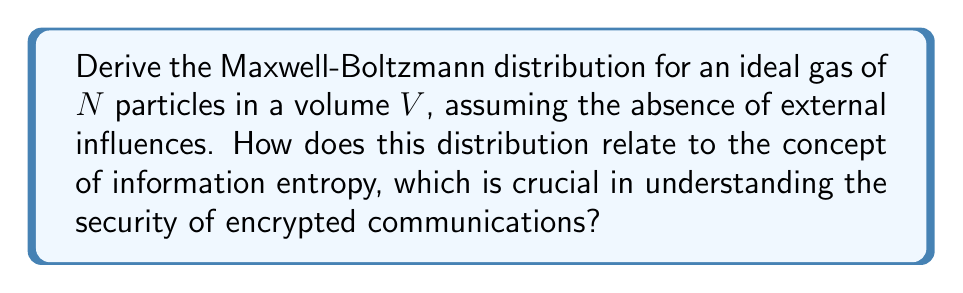Can you answer this question? Let's derive the Maxwell-Boltzmann distribution step-by-step:

1) We start with the canonical ensemble partition function:

   $$Z = \sum_i e^{-\beta E_i}$$

   where $\beta = \frac{1}{k_B T}$, $k_B$ is Boltzmann's constant, and T is temperature.

2) For an ideal gas, the energy is purely kinetic:

   $$E = \frac{1}{2}m(v_x^2 + v_y^2 + v_z^2)$$

3) The partition function becomes:

   $$Z = \left(\frac{V}{h^3}\right)^N \int e^{-\beta \frac{1}{2}m(v_x^2 + v_y^2 + v_z^2)} dv_x dv_y dv_z$$

4) This integral can be separated into three identical integrals:

   $$Z = \left(\frac{V}{h^3}\right)^N \left(\int e^{-\beta \frac{1}{2}mv_x^2} dv_x\right)^3$$

5) Each integral is a Gaussian integral with solution:

   $$\int e^{-\beta \frac{1}{2}mv_x^2} dv_x = \sqrt{\frac{2\pi}{\beta m}}$$

6) Substituting back:

   $$Z = \left(\frac{V}{h^3}\right)^N \left(\frac{2\pi m}{\beta}\right)^{3N/2}$$

7) The probability of finding a particle with velocity between $\vec{v}$ and $\vec{v} + d\vec{v}$ is:

   $$P(\vec{v})d\vec{v} = \frac{1}{Z} e^{-\beta \frac{1}{2}m(v_x^2 + v_y^2 + v_z^2)} d\vec{v}$$

8) Substituting Z and simplifying:

   $$P(\vec{v}) = \left(\frac{m}{2\pi k_B T}\right)^{3/2} e^{-\frac{m(v_x^2 + v_y^2 + v_z^2)}{2k_B T}}$$

This is the Maxwell-Boltzmann distribution.

Regarding information entropy, the Maxwell-Boltzmann distribution maximizes the Gibbs entropy:

$$S = -k_B \sum_i p_i \ln p_i$$

This is analogous to Shannon entropy in information theory:

$$H = -\sum_i p_i \log_2 p_i$$

Both measure the uncertainty or randomness in a system. In cryptography, high entropy is desired for secure encryption keys, as it increases the difficulty of guessing or breaking the encryption.
Answer: $$P(\vec{v}) = \left(\frac{m}{2\pi k_B T}\right)^{3/2} e^{-\frac{m(v_x^2 + v_y^2 + v_z^2)}{2k_B T}}$$ 